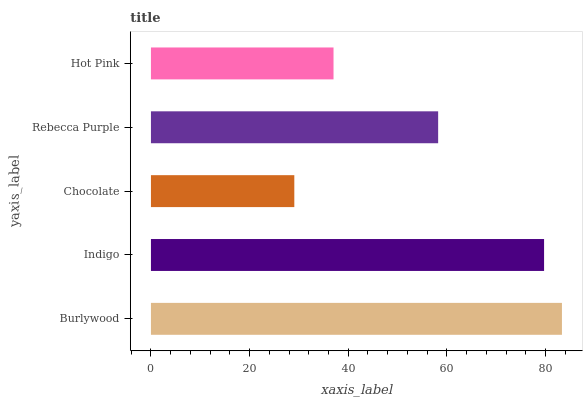Is Chocolate the minimum?
Answer yes or no. Yes. Is Burlywood the maximum?
Answer yes or no. Yes. Is Indigo the minimum?
Answer yes or no. No. Is Indigo the maximum?
Answer yes or no. No. Is Burlywood greater than Indigo?
Answer yes or no. Yes. Is Indigo less than Burlywood?
Answer yes or no. Yes. Is Indigo greater than Burlywood?
Answer yes or no. No. Is Burlywood less than Indigo?
Answer yes or no. No. Is Rebecca Purple the high median?
Answer yes or no. Yes. Is Rebecca Purple the low median?
Answer yes or no. Yes. Is Burlywood the high median?
Answer yes or no. No. Is Burlywood the low median?
Answer yes or no. No. 